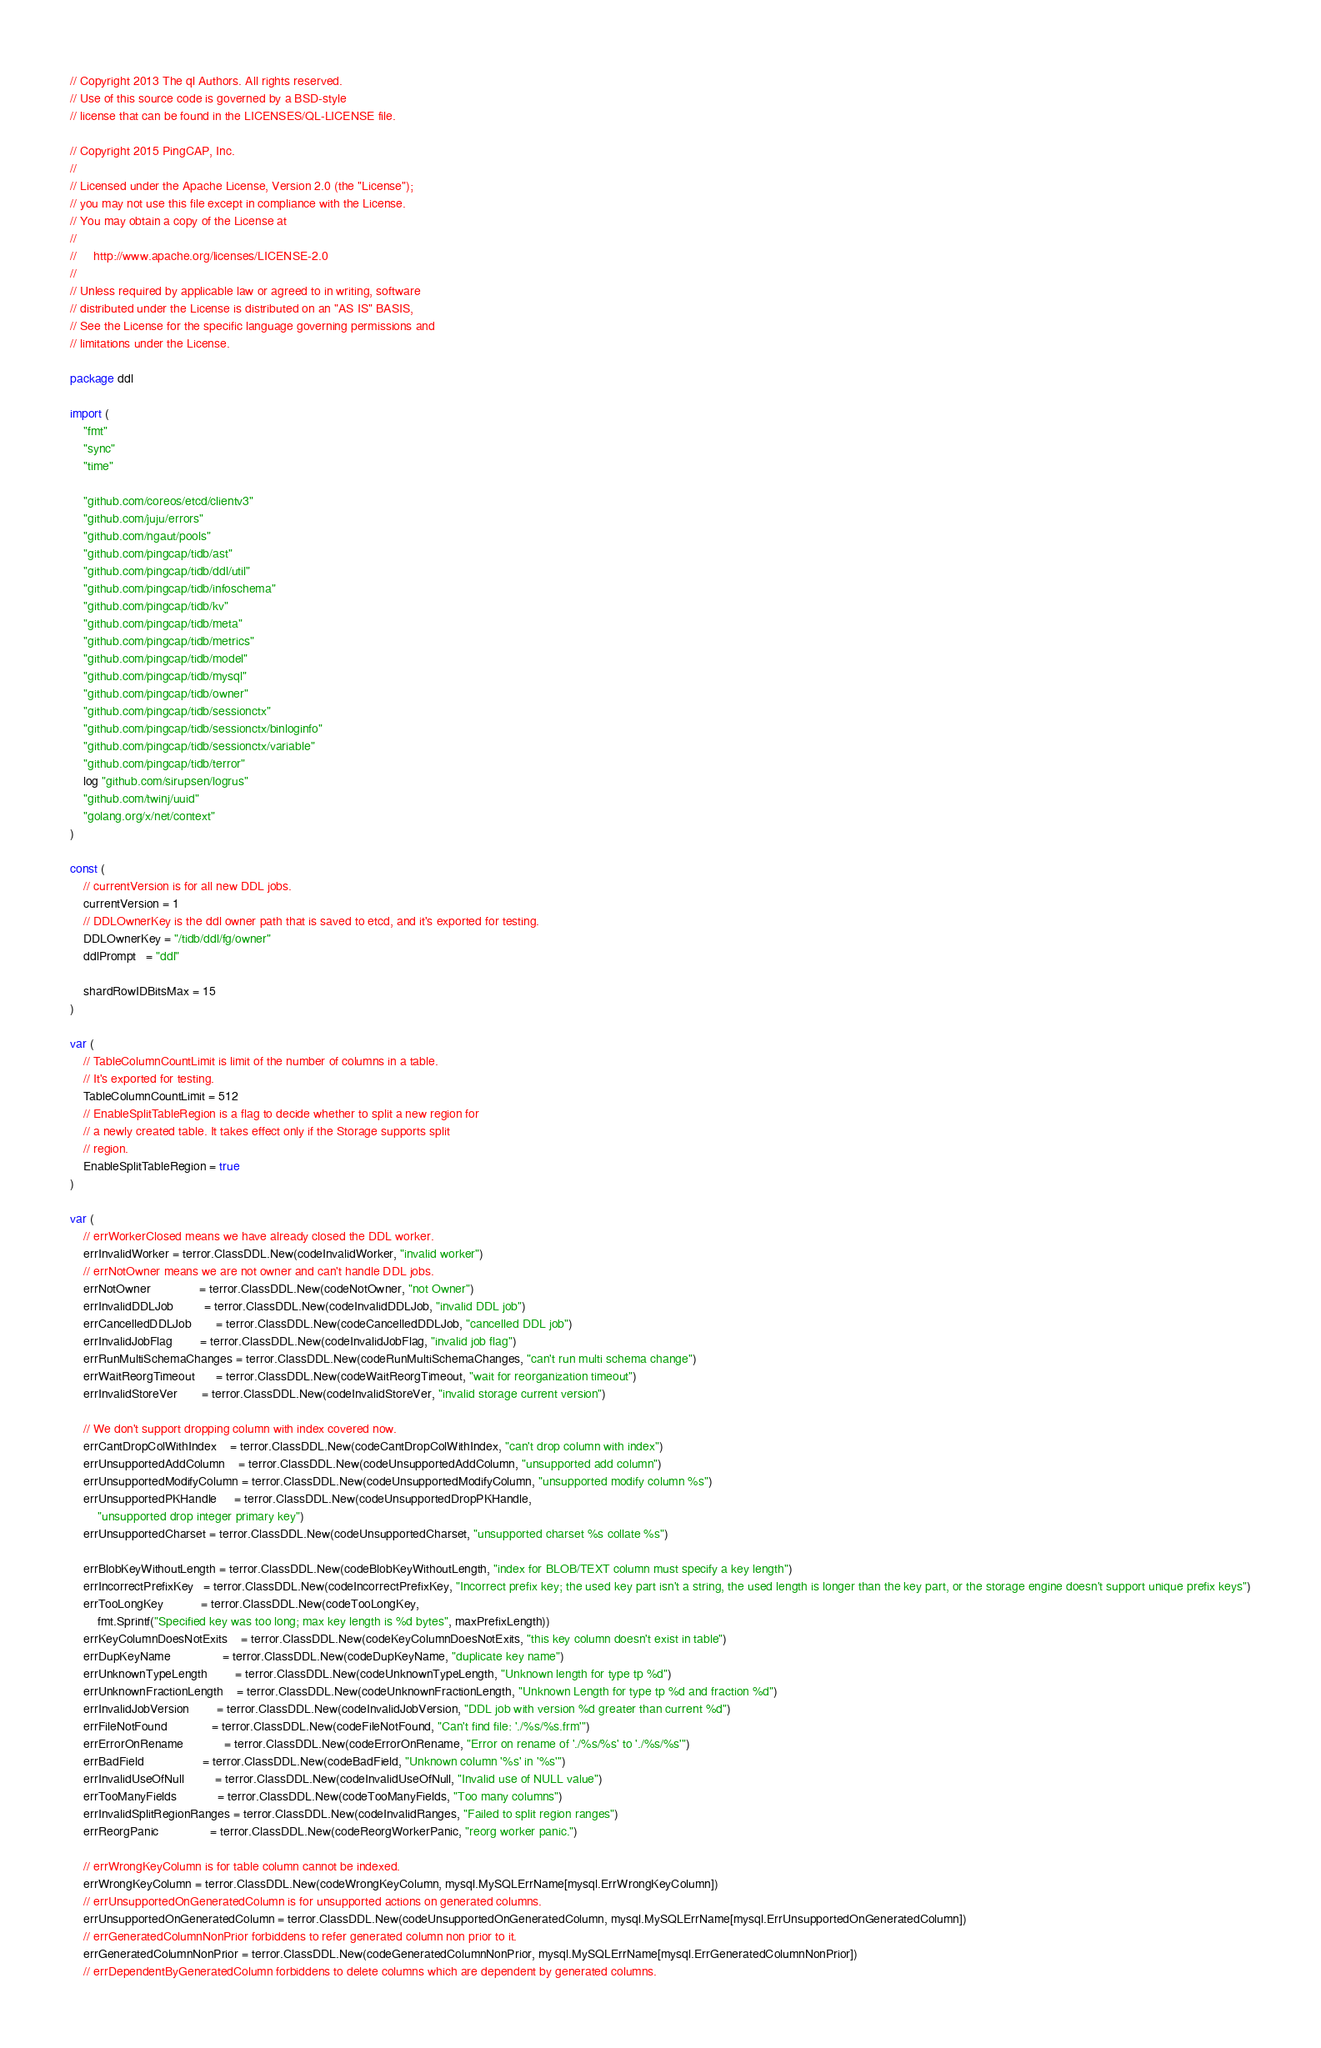<code> <loc_0><loc_0><loc_500><loc_500><_Go_>// Copyright 2013 The ql Authors. All rights reserved.
// Use of this source code is governed by a BSD-style
// license that can be found in the LICENSES/QL-LICENSE file.

// Copyright 2015 PingCAP, Inc.
//
// Licensed under the Apache License, Version 2.0 (the "License");
// you may not use this file except in compliance with the License.
// You may obtain a copy of the License at
//
//     http://www.apache.org/licenses/LICENSE-2.0
//
// Unless required by applicable law or agreed to in writing, software
// distributed under the License is distributed on an "AS IS" BASIS,
// See the License for the specific language governing permissions and
// limitations under the License.

package ddl

import (
	"fmt"
	"sync"
	"time"

	"github.com/coreos/etcd/clientv3"
	"github.com/juju/errors"
	"github.com/ngaut/pools"
	"github.com/pingcap/tidb/ast"
	"github.com/pingcap/tidb/ddl/util"
	"github.com/pingcap/tidb/infoschema"
	"github.com/pingcap/tidb/kv"
	"github.com/pingcap/tidb/meta"
	"github.com/pingcap/tidb/metrics"
	"github.com/pingcap/tidb/model"
	"github.com/pingcap/tidb/mysql"
	"github.com/pingcap/tidb/owner"
	"github.com/pingcap/tidb/sessionctx"
	"github.com/pingcap/tidb/sessionctx/binloginfo"
	"github.com/pingcap/tidb/sessionctx/variable"
	"github.com/pingcap/tidb/terror"
	log "github.com/sirupsen/logrus"
	"github.com/twinj/uuid"
	"golang.org/x/net/context"
)

const (
	// currentVersion is for all new DDL jobs.
	currentVersion = 1
	// DDLOwnerKey is the ddl owner path that is saved to etcd, and it's exported for testing.
	DDLOwnerKey = "/tidb/ddl/fg/owner"
	ddlPrompt   = "ddl"

	shardRowIDBitsMax = 15
)

var (
	// TableColumnCountLimit is limit of the number of columns in a table.
	// It's exported for testing.
	TableColumnCountLimit = 512
	// EnableSplitTableRegion is a flag to decide whether to split a new region for
	// a newly created table. It takes effect only if the Storage supports split
	// region.
	EnableSplitTableRegion = true
)

var (
	// errWorkerClosed means we have already closed the DDL worker.
	errInvalidWorker = terror.ClassDDL.New(codeInvalidWorker, "invalid worker")
	// errNotOwner means we are not owner and can't handle DDL jobs.
	errNotOwner              = terror.ClassDDL.New(codeNotOwner, "not Owner")
	errInvalidDDLJob         = terror.ClassDDL.New(codeInvalidDDLJob, "invalid DDL job")
	errCancelledDDLJob       = terror.ClassDDL.New(codeCancelledDDLJob, "cancelled DDL job")
	errInvalidJobFlag        = terror.ClassDDL.New(codeInvalidJobFlag, "invalid job flag")
	errRunMultiSchemaChanges = terror.ClassDDL.New(codeRunMultiSchemaChanges, "can't run multi schema change")
	errWaitReorgTimeout      = terror.ClassDDL.New(codeWaitReorgTimeout, "wait for reorganization timeout")
	errInvalidStoreVer       = terror.ClassDDL.New(codeInvalidStoreVer, "invalid storage current version")

	// We don't support dropping column with index covered now.
	errCantDropColWithIndex    = terror.ClassDDL.New(codeCantDropColWithIndex, "can't drop column with index")
	errUnsupportedAddColumn    = terror.ClassDDL.New(codeUnsupportedAddColumn, "unsupported add column")
	errUnsupportedModifyColumn = terror.ClassDDL.New(codeUnsupportedModifyColumn, "unsupported modify column %s")
	errUnsupportedPKHandle     = terror.ClassDDL.New(codeUnsupportedDropPKHandle,
		"unsupported drop integer primary key")
	errUnsupportedCharset = terror.ClassDDL.New(codeUnsupportedCharset, "unsupported charset %s collate %s")

	errBlobKeyWithoutLength = terror.ClassDDL.New(codeBlobKeyWithoutLength, "index for BLOB/TEXT column must specify a key length")
	errIncorrectPrefixKey   = terror.ClassDDL.New(codeIncorrectPrefixKey, "Incorrect prefix key; the used key part isn't a string, the used length is longer than the key part, or the storage engine doesn't support unique prefix keys")
	errTooLongKey           = terror.ClassDDL.New(codeTooLongKey,
		fmt.Sprintf("Specified key was too long; max key length is %d bytes", maxPrefixLength))
	errKeyColumnDoesNotExits    = terror.ClassDDL.New(codeKeyColumnDoesNotExits, "this key column doesn't exist in table")
	errDupKeyName               = terror.ClassDDL.New(codeDupKeyName, "duplicate key name")
	errUnknownTypeLength        = terror.ClassDDL.New(codeUnknownTypeLength, "Unknown length for type tp %d")
	errUnknownFractionLength    = terror.ClassDDL.New(codeUnknownFractionLength, "Unknown Length for type tp %d and fraction %d")
	errInvalidJobVersion        = terror.ClassDDL.New(codeInvalidJobVersion, "DDL job with version %d greater than current %d")
	errFileNotFound             = terror.ClassDDL.New(codeFileNotFound, "Can't find file: './%s/%s.frm'")
	errErrorOnRename            = terror.ClassDDL.New(codeErrorOnRename, "Error on rename of './%s/%s' to './%s/%s'")
	errBadField                 = terror.ClassDDL.New(codeBadField, "Unknown column '%s' in '%s'")
	errInvalidUseOfNull         = terror.ClassDDL.New(codeInvalidUseOfNull, "Invalid use of NULL value")
	errTooManyFields            = terror.ClassDDL.New(codeTooManyFields, "Too many columns")
	errInvalidSplitRegionRanges = terror.ClassDDL.New(codeInvalidRanges, "Failed to split region ranges")
	errReorgPanic               = terror.ClassDDL.New(codeReorgWorkerPanic, "reorg worker panic.")

	// errWrongKeyColumn is for table column cannot be indexed.
	errWrongKeyColumn = terror.ClassDDL.New(codeWrongKeyColumn, mysql.MySQLErrName[mysql.ErrWrongKeyColumn])
	// errUnsupportedOnGeneratedColumn is for unsupported actions on generated columns.
	errUnsupportedOnGeneratedColumn = terror.ClassDDL.New(codeUnsupportedOnGeneratedColumn, mysql.MySQLErrName[mysql.ErrUnsupportedOnGeneratedColumn])
	// errGeneratedColumnNonPrior forbiddens to refer generated column non prior to it.
	errGeneratedColumnNonPrior = terror.ClassDDL.New(codeGeneratedColumnNonPrior, mysql.MySQLErrName[mysql.ErrGeneratedColumnNonPrior])
	// errDependentByGeneratedColumn forbiddens to delete columns which are dependent by generated columns.</code> 